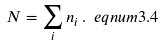Convert formula to latex. <formula><loc_0><loc_0><loc_500><loc_500>N = \sum _ { i } n _ { i } \, . \ e q n u m { 3 . 4 }</formula> 